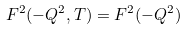Convert formula to latex. <formula><loc_0><loc_0><loc_500><loc_500>F ^ { 2 } ( - Q ^ { 2 } , T ) = F ^ { 2 } ( - Q ^ { 2 } )</formula> 